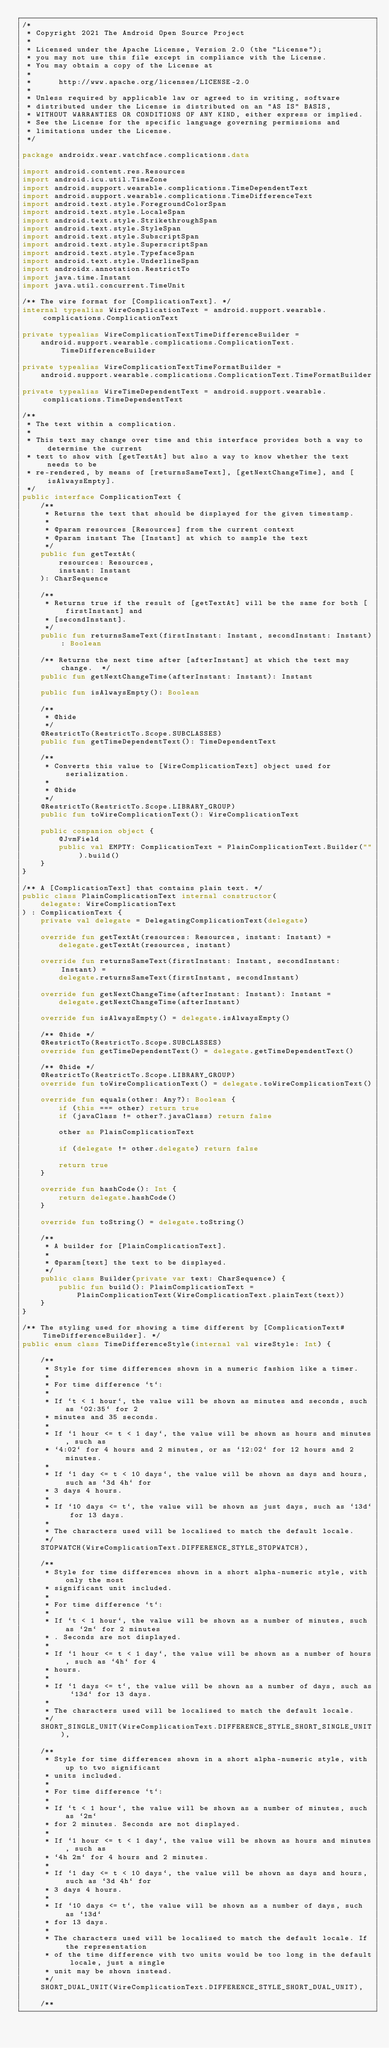Convert code to text. <code><loc_0><loc_0><loc_500><loc_500><_Kotlin_>/*
 * Copyright 2021 The Android Open Source Project
 *
 * Licensed under the Apache License, Version 2.0 (the "License");
 * you may not use this file except in compliance with the License.
 * You may obtain a copy of the License at
 *
 *      http://www.apache.org/licenses/LICENSE-2.0
 *
 * Unless required by applicable law or agreed to in writing, software
 * distributed under the License is distributed on an "AS IS" BASIS,
 * WITHOUT WARRANTIES OR CONDITIONS OF ANY KIND, either express or implied.
 * See the License for the specific language governing permissions and
 * limitations under the License.
 */

package androidx.wear.watchface.complications.data

import android.content.res.Resources
import android.icu.util.TimeZone
import android.support.wearable.complications.TimeDependentText
import android.support.wearable.complications.TimeDifferenceText
import android.text.style.ForegroundColorSpan
import android.text.style.LocaleSpan
import android.text.style.StrikethroughSpan
import android.text.style.StyleSpan
import android.text.style.SubscriptSpan
import android.text.style.SuperscriptSpan
import android.text.style.TypefaceSpan
import android.text.style.UnderlineSpan
import androidx.annotation.RestrictTo
import java.time.Instant
import java.util.concurrent.TimeUnit

/** The wire format for [ComplicationText]. */
internal typealias WireComplicationText = android.support.wearable.complications.ComplicationText

private typealias WireComplicationTextTimeDifferenceBuilder =
    android.support.wearable.complications.ComplicationText.TimeDifferenceBuilder

private typealias WireComplicationTextTimeFormatBuilder =
    android.support.wearable.complications.ComplicationText.TimeFormatBuilder

private typealias WireTimeDependentText = android.support.wearable.complications.TimeDependentText

/**
 * The text within a complication.
 *
 * This text may change over time and this interface provides both a way to determine the current
 * text to show with [getTextAt] but also a way to know whether the text needs to be
 * re-rendered, by means of [returnsSameText], [getNextChangeTime], and [isAlwaysEmpty].
 */
public interface ComplicationText {
    /**
     * Returns the text that should be displayed for the given timestamp.
     *
     * @param resources [Resources] from the current context
     * @param instant The [Instant] at which to sample the text
     */
    public fun getTextAt(
        resources: Resources,
        instant: Instant
    ): CharSequence

    /**
     * Returns true if the result of [getTextAt] will be the same for both [firstInstant] and
     * [secondInstant].
     */
    public fun returnsSameText(firstInstant: Instant, secondInstant: Instant): Boolean

    /** Returns the next time after [afterInstant] at which the text may change.  */
    public fun getNextChangeTime(afterInstant: Instant): Instant

    public fun isAlwaysEmpty(): Boolean

    /**
     * @hide
     */
    @RestrictTo(RestrictTo.Scope.SUBCLASSES)
    public fun getTimeDependentText(): TimeDependentText

    /**
     * Converts this value to [WireComplicationText] object used for serialization.
     *
     * @hide
     */
    @RestrictTo(RestrictTo.Scope.LIBRARY_GROUP)
    public fun toWireComplicationText(): WireComplicationText

    public companion object {
        @JvmField
        public val EMPTY: ComplicationText = PlainComplicationText.Builder("").build()
    }
}

/** A [ComplicationText] that contains plain text. */
public class PlainComplicationText internal constructor(
    delegate: WireComplicationText
) : ComplicationText {
    private val delegate = DelegatingComplicationText(delegate)

    override fun getTextAt(resources: Resources, instant: Instant) =
        delegate.getTextAt(resources, instant)

    override fun returnsSameText(firstInstant: Instant, secondInstant: Instant) =
        delegate.returnsSameText(firstInstant, secondInstant)

    override fun getNextChangeTime(afterInstant: Instant): Instant =
        delegate.getNextChangeTime(afterInstant)

    override fun isAlwaysEmpty() = delegate.isAlwaysEmpty()

    /** @hide */
    @RestrictTo(RestrictTo.Scope.SUBCLASSES)
    override fun getTimeDependentText() = delegate.getTimeDependentText()

    /** @hide */
    @RestrictTo(RestrictTo.Scope.LIBRARY_GROUP)
    override fun toWireComplicationText() = delegate.toWireComplicationText()

    override fun equals(other: Any?): Boolean {
        if (this === other) return true
        if (javaClass != other?.javaClass) return false

        other as PlainComplicationText

        if (delegate != other.delegate) return false

        return true
    }

    override fun hashCode(): Int {
        return delegate.hashCode()
    }

    override fun toString() = delegate.toString()

    /**
     * A builder for [PlainComplicationText].
     *
     * @param[text] the text to be displayed.
     */
    public class Builder(private var text: CharSequence) {
        public fun build(): PlainComplicationText =
            PlainComplicationText(WireComplicationText.plainText(text))
    }
}

/** The styling used for showing a time different by [ComplicationText#TimeDifferenceBuilder]. */
public enum class TimeDifferenceStyle(internal val wireStyle: Int) {

    /**
     * Style for time differences shown in a numeric fashion like a timer.
     *
     * For time difference `t`:
     *
     * If `t < 1 hour`, the value will be shown as minutes and seconds, such as `02:35` for 2
     * minutes and 35 seconds.
     *
     * If `1 hour <= t < 1 day`, the value will be shown as hours and minutes, such as
     * `4:02` for 4 hours and 2 minutes, or as `12:02` for 12 hours and 2 minutes.
     *
     * If `1 day <= t < 10 days`, the value will be shown as days and hours, such as `3d 4h` for
     * 3 days 4 hours.
     *
     * If `10 days <= t`, the value will be shown as just days, such as `13d` for 13 days.
     *
     * The characters used will be localised to match the default locale.
     */
    STOPWATCH(WireComplicationText.DIFFERENCE_STYLE_STOPWATCH),

    /**
     * Style for time differences shown in a short alpha-numeric style, with only the most
     * significant unit included.
     *
     * For time difference `t`:
     *
     * If `t < 1 hour`, the value will be shown as a number of minutes, such as `2m` for 2 minutes
     * . Seconds are not displayed.
     *
     * If `1 hour <= t < 1 day`, the value will be shown as a number of hours, such as `4h` for 4
     * hours.
     *
     * If `1 days <= t`, the value will be shown as a number of days, such as `13d` for 13 days.
     *
     * The characters used will be localised to match the default locale.
     */
    SHORT_SINGLE_UNIT(WireComplicationText.DIFFERENCE_STYLE_SHORT_SINGLE_UNIT),

    /**
     * Style for time differences shown in a short alpha-numeric style, with up to two significant
     * units included.
     *
     * For time difference `t`:
     *
     * If `t < 1 hour`, the value will be shown as a number of minutes, such as `2m`
     * for 2 minutes. Seconds are not displayed.
     *
     * If `1 hour <= t < 1 day`, the value will be shown as hours and minutes, such as
     * `4h 2m` for 4 hours and 2 minutes.
     *
     * If `1 day <= t < 10 days`, the value will be shown as days and hours, such as `3d 4h` for
     * 3 days 4 hours.
     *
     * If `10 days <= t`, the value will be shown as a number of days, such as `13d`
     * for 13 days.
     *
     * The characters used will be localised to match the default locale. If the representation
     * of the time difference with two units would be too long in the default locale, just a single
     * unit may be shown instead.
     */
    SHORT_DUAL_UNIT(WireComplicationText.DIFFERENCE_STYLE_SHORT_DUAL_UNIT),

    /**</code> 